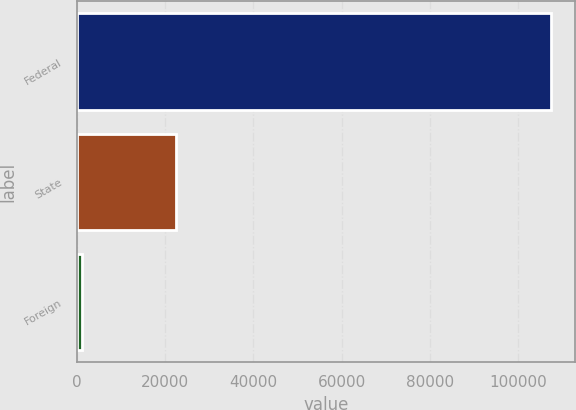Convert chart to OTSL. <chart><loc_0><loc_0><loc_500><loc_500><bar_chart><fcel>Federal<fcel>State<fcel>Foreign<nl><fcel>107503<fcel>22332<fcel>1233<nl></chart> 